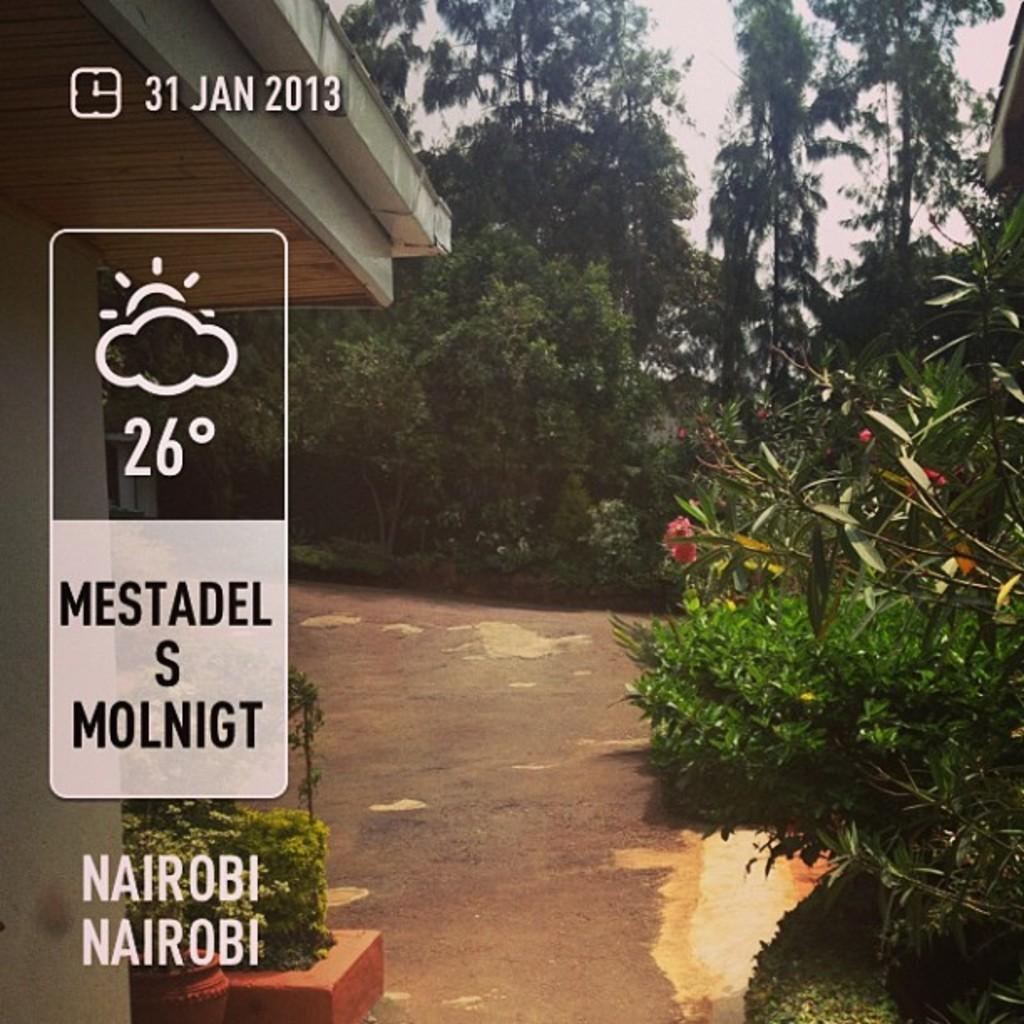Please provide a concise description of this image. In this image we can see a picture. In the left side of the image we can see a building, some text and some plants. In the right side of the image we can see group of flowers on plants, trees, a shed and in the background we can see the sky. 